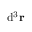Convert formula to latex. <formula><loc_0><loc_0><loc_500><loc_500>d ^ { 3 } r</formula> 